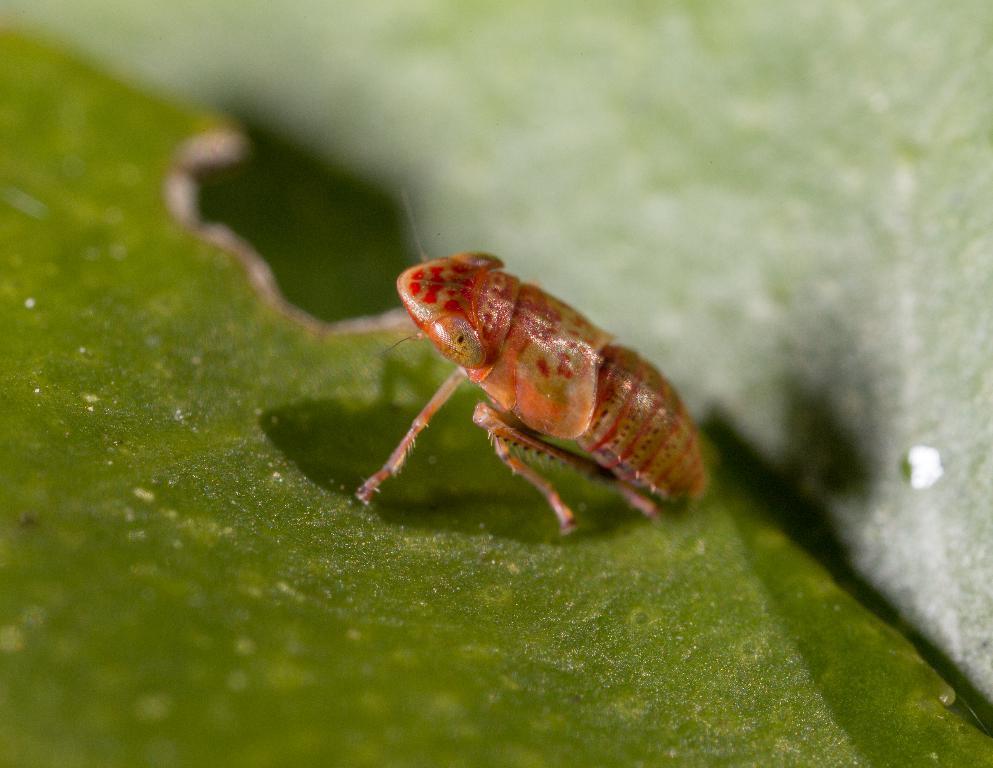In one or two sentences, can you explain what this image depicts? In this picture we can see an insect on a leaf and in the background we can see it is blurry. 